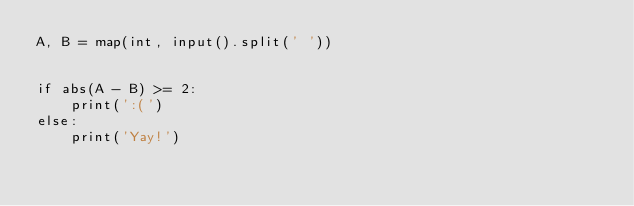<code> <loc_0><loc_0><loc_500><loc_500><_Python_>A, B = map(int, input().split(' '))


if abs(A - B) >= 2:
    print(':(')
else:
    print('Yay!')</code> 